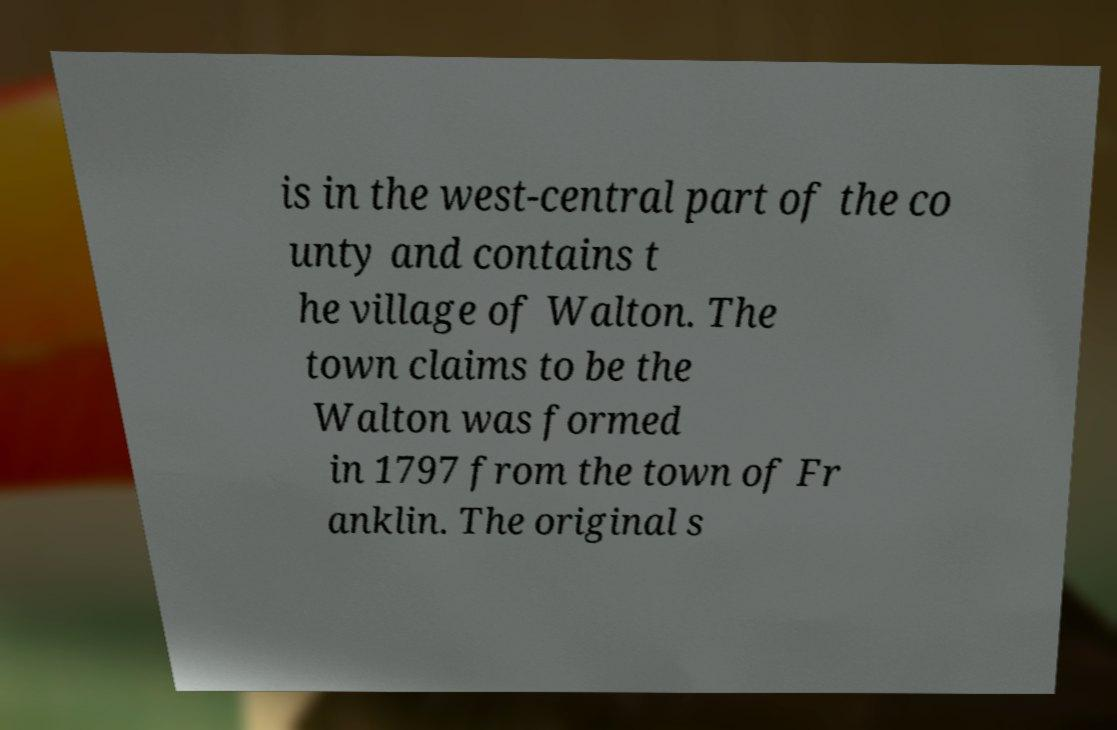Could you extract and type out the text from this image? is in the west-central part of the co unty and contains t he village of Walton. The town claims to be the Walton was formed in 1797 from the town of Fr anklin. The original s 